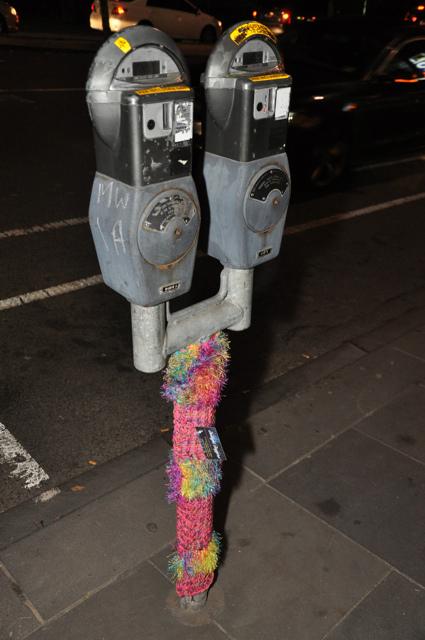What is the dominant color that the meter is decorated?
Keep it brief. Pink. What colors are on the bottom of the parking meter?
Short answer required. Pink. Is it likely that the pink accessory was installed by a government official?
Answer briefly. No. How much do you think it costs to park at these meters?
Be succinct. 1 dollar. 